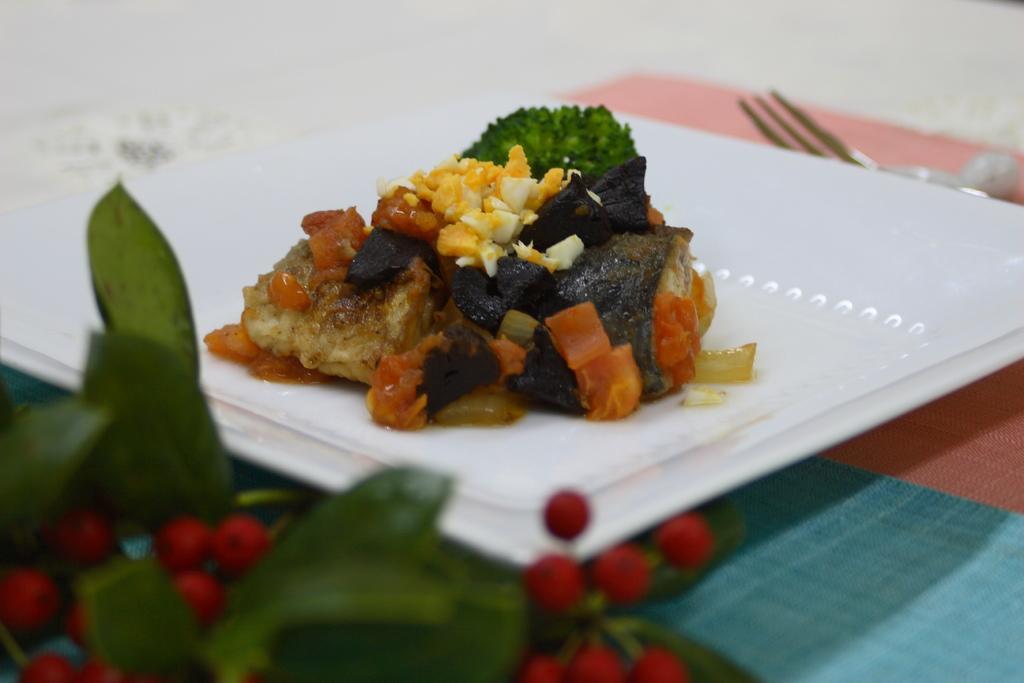In one or two sentences, can you explain what this image depicts? In this image I can see a white color plate ,on the plate I can see a food item and on the table I can see a fork ,in the bottom left i can see fruits and leaves. 